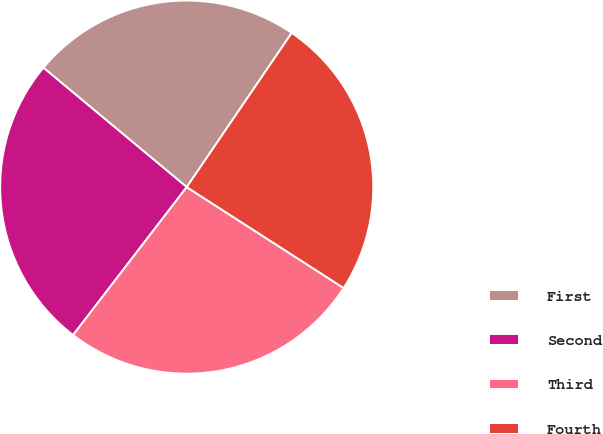Convert chart. <chart><loc_0><loc_0><loc_500><loc_500><pie_chart><fcel>First<fcel>Second<fcel>Third<fcel>Fourth<nl><fcel>23.46%<fcel>25.63%<fcel>26.33%<fcel>24.58%<nl></chart> 